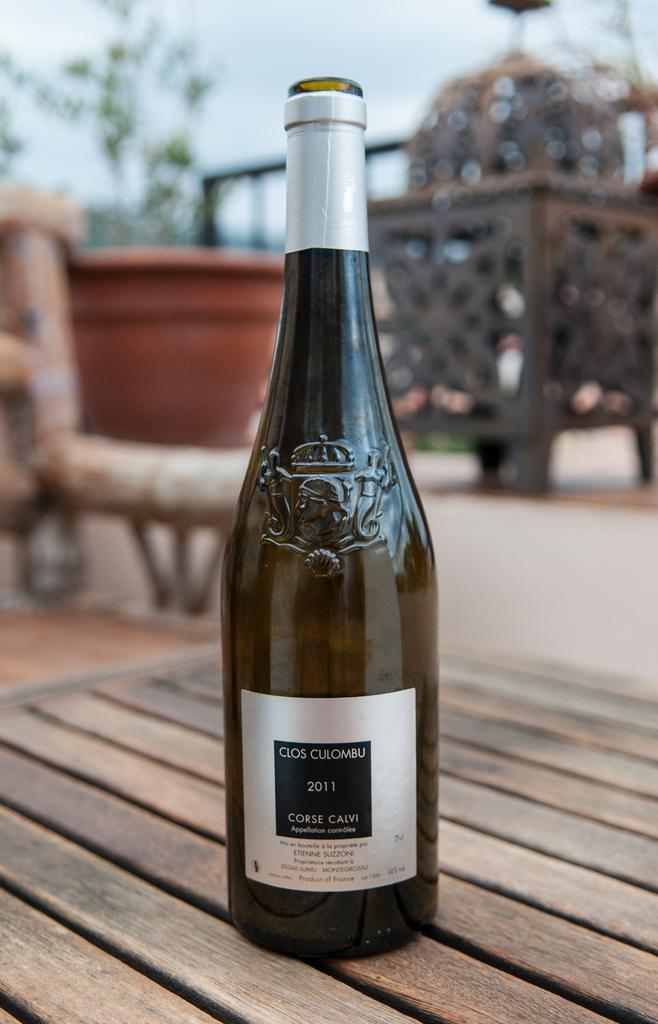<image>
Summarize the visual content of the image. A bottle of Clos Culombu wine from 2011. 